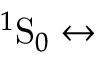<formula> <loc_0><loc_0><loc_500><loc_500>{ ^ { 1 } } S _ { 0 } \leftrightarrow</formula> 